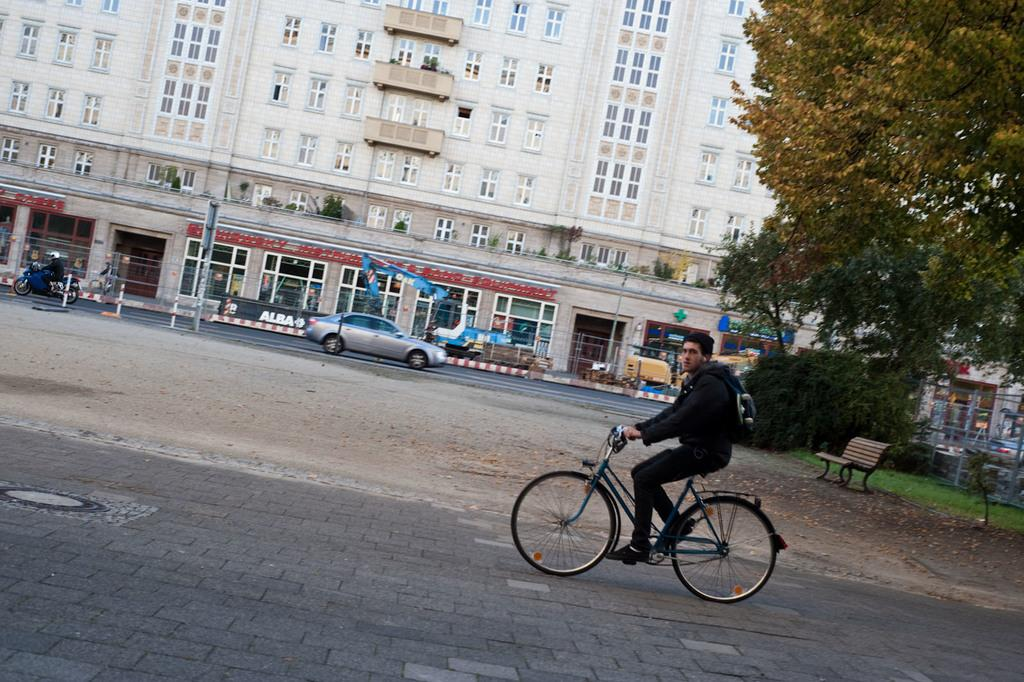What is the man in the image doing? The man is riding a bicycle in the image. Where is the man riding the bicycle? The bicycle is on a road in the image. What can be seen in the background of the image? There are trees, buildings, vehicles, and a bench in the background of the image. What type of finger can be seen holding the handlebar of the bicycle in the image? There is no finger visible in the image; it is the man's hand that is holding the handlebar. How does the man generate power to ride the bicycle in the image? The man generates power by pedaling the bicycle, not by using any external power source. 